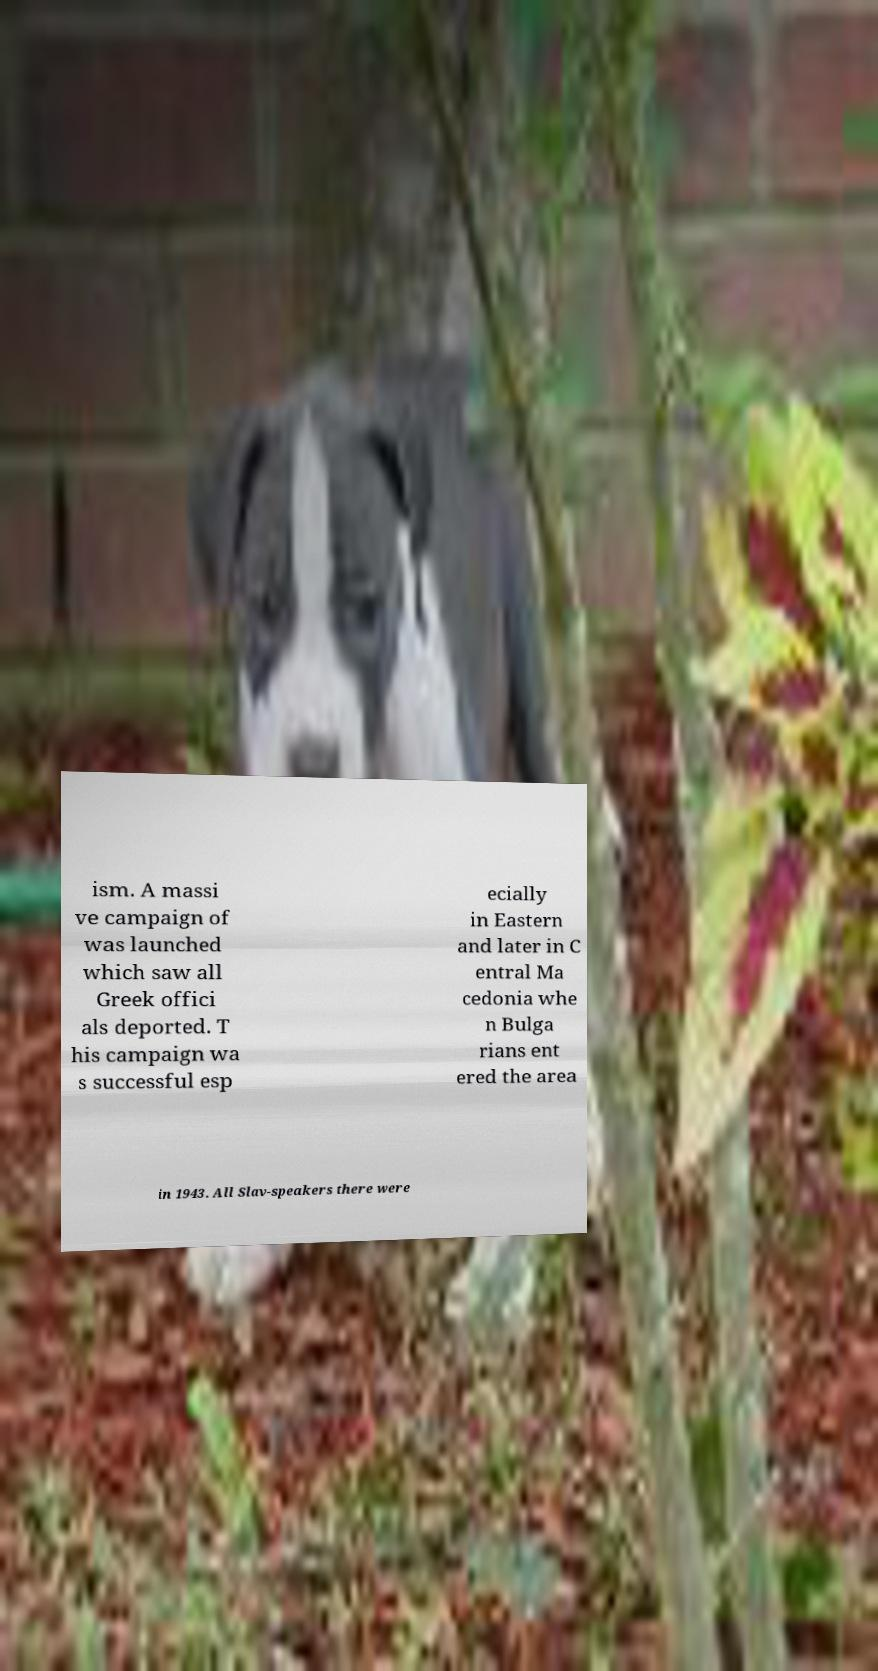Please read and relay the text visible in this image. What does it say? ism. A massi ve campaign of was launched which saw all Greek offici als deported. T his campaign wa s successful esp ecially in Eastern and later in C entral Ma cedonia whe n Bulga rians ent ered the area in 1943. All Slav-speakers there were 